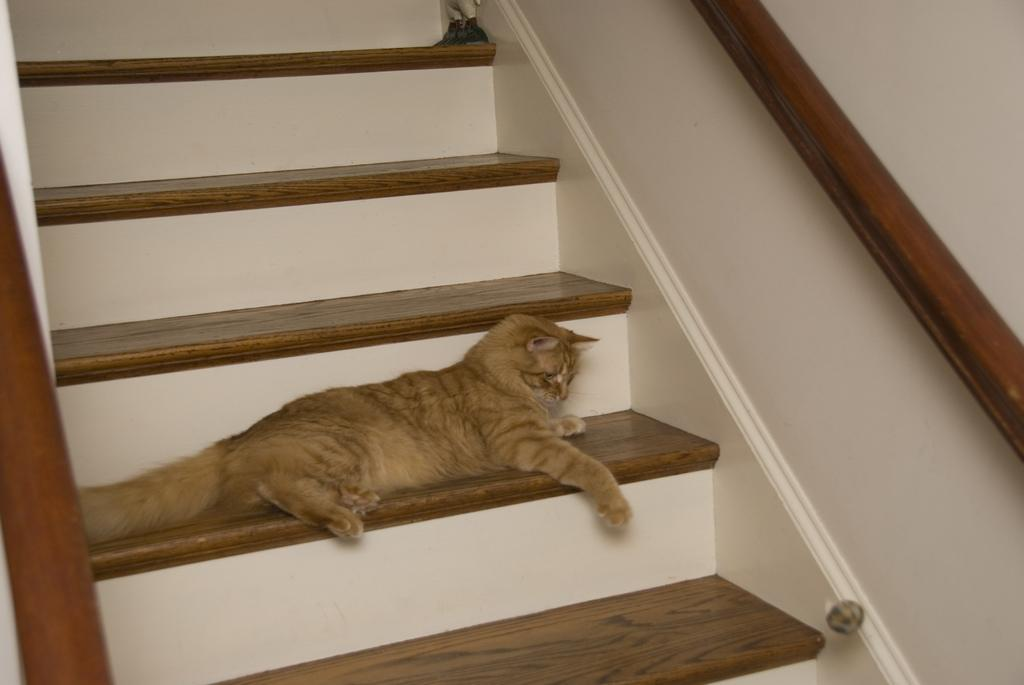What is the main subject in the foreground of the image? There is a cat in the foreground of the image. Where is the cat located? The cat is on the stairs. What can be seen on either side of the stairs? There is railing on either side of the stairs. What is visible on the right side of the image? There is a wall on the right side of the image. What type of insurance policy is the cat holding in the image? There is no insurance policy present in the image, and the cat is not holding anything. How many cherries can be seen on the wall in the image? There are no cherries visible in the image; only the cat, stairs, railing, and wall are present. 